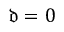Convert formula to latex. <formula><loc_0><loc_0><loc_500><loc_500>\mathfrak { d } = 0</formula> 